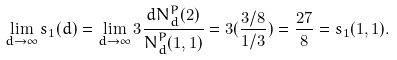Convert formula to latex. <formula><loc_0><loc_0><loc_500><loc_500>\lim _ { d \to \infty } s _ { 1 } ( d ) = \lim _ { d \to \infty } 3 \frac { d N _ { d } ^ { P } ( 2 ) } { N _ { d } ^ { P } ( 1 , 1 ) } = 3 ( \frac { 3 / 8 } { 1 / 3 } ) = \frac { 2 7 } { 8 } = s _ { 1 } ( 1 , 1 ) .</formula> 